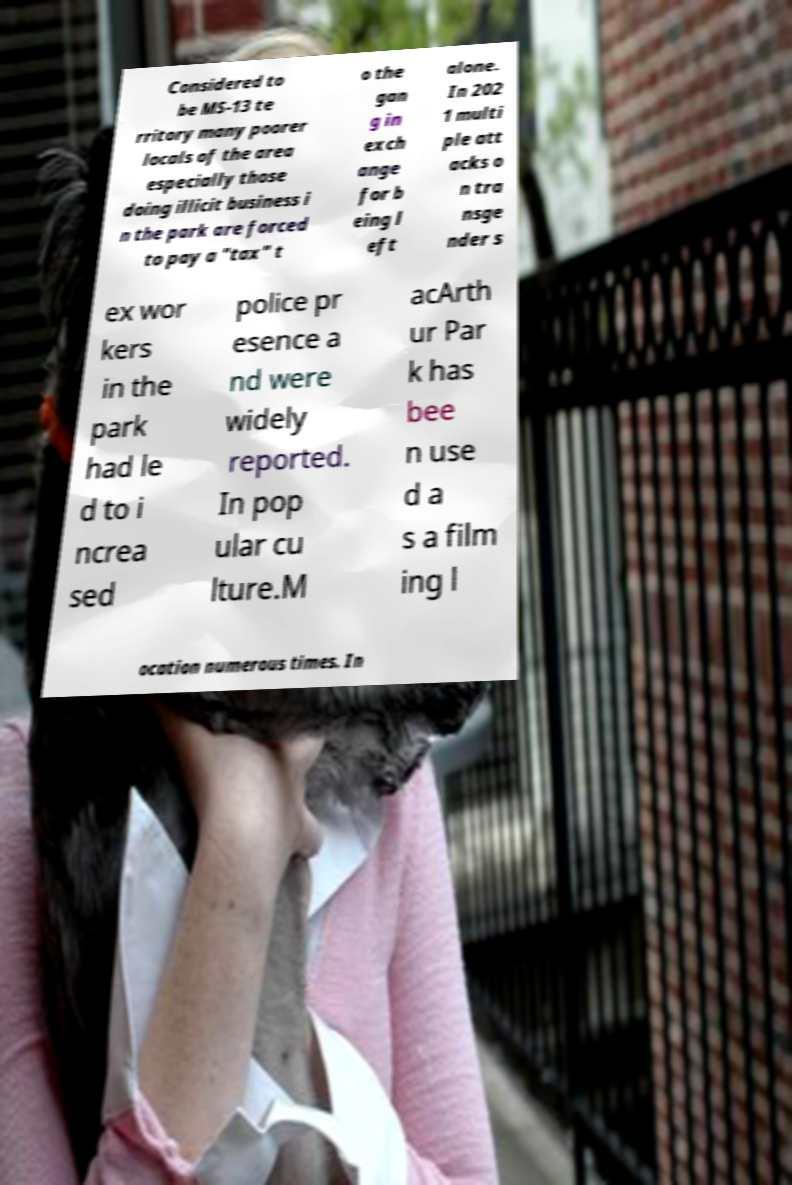Please read and relay the text visible in this image. What does it say? Considered to be MS-13 te rritory many poorer locals of the area especially those doing illicit business i n the park are forced to pay a "tax" t o the gan g in exch ange for b eing l eft alone. In 202 1 multi ple att acks o n tra nsge nder s ex wor kers in the park had le d to i ncrea sed police pr esence a nd were widely reported. In pop ular cu lture.M acArth ur Par k has bee n use d a s a film ing l ocation numerous times. In 